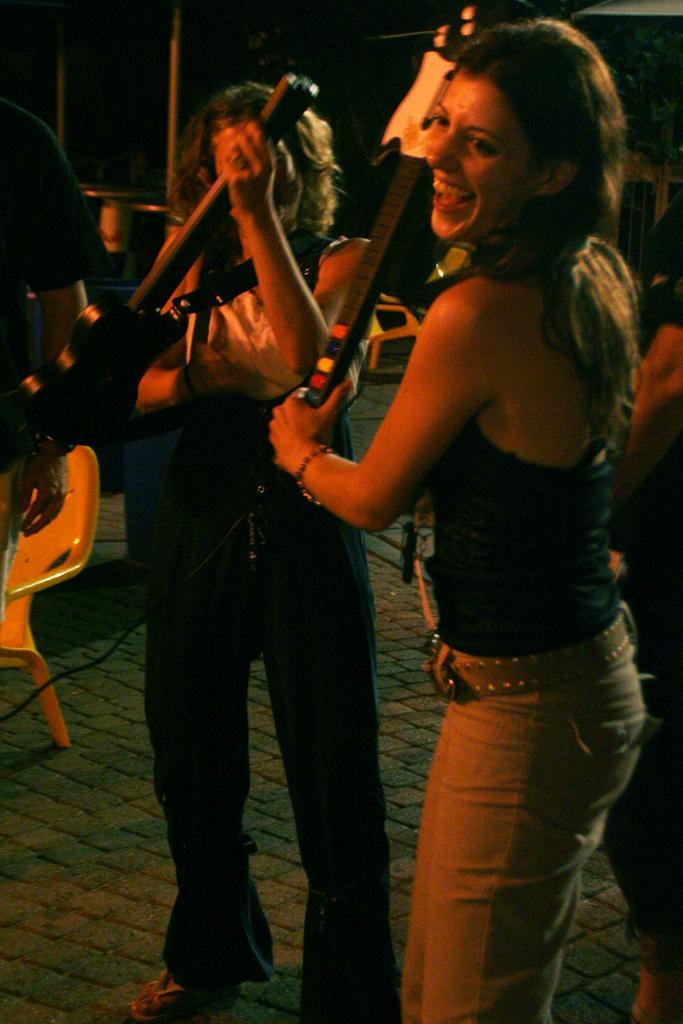Describe this image in one or two sentences. In this picture we can see woman standing holding guitar in her hand and she is smiling and in the background we can see woman standing and holding guitar, chair, floor and pillars. 